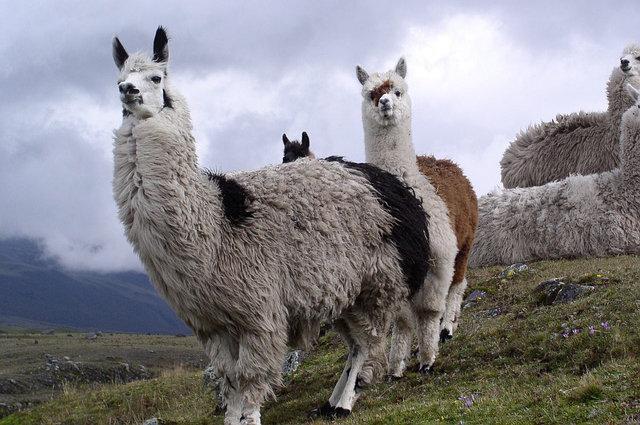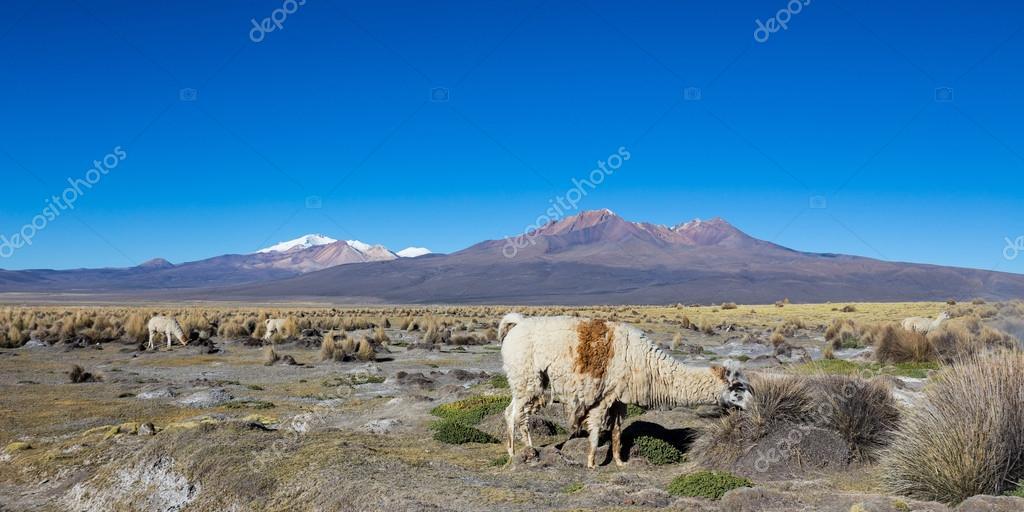The first image is the image on the left, the second image is the image on the right. Evaluate the accuracy of this statement regarding the images: "The left image shows a small group of different colored llamas who aren't wearing anything, and the right image inludes at least one rightward-facing llama who is grazing.". Is it true? Answer yes or no. Yes. 